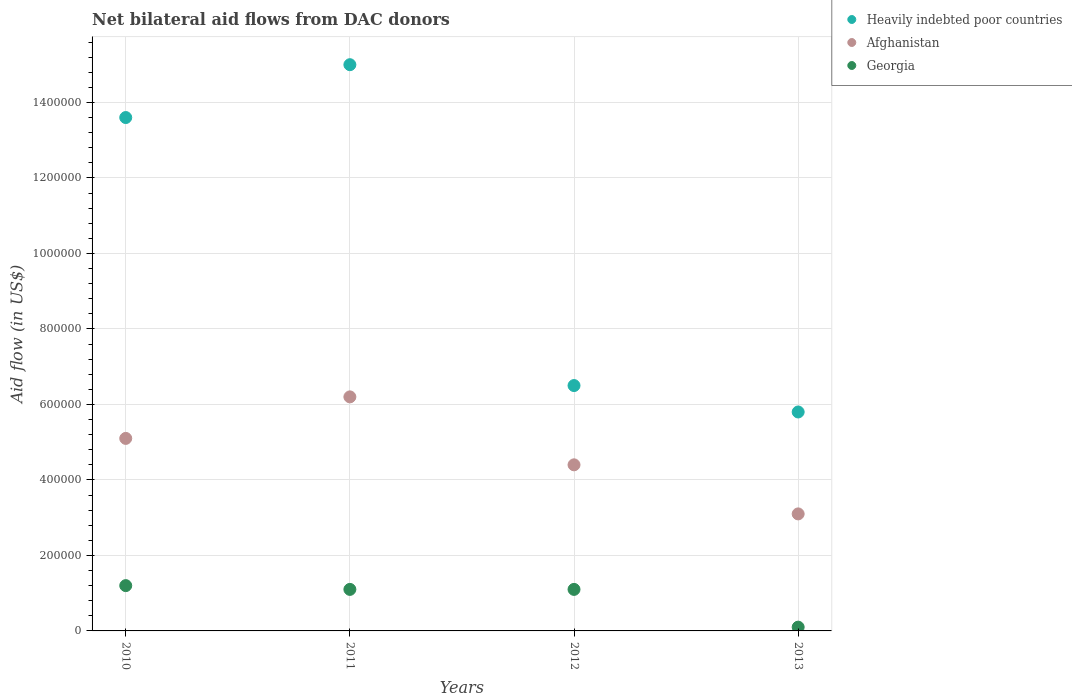What is the net bilateral aid flow in Heavily indebted poor countries in 2010?
Offer a terse response. 1.36e+06. Across all years, what is the maximum net bilateral aid flow in Afghanistan?
Keep it short and to the point. 6.20e+05. Across all years, what is the minimum net bilateral aid flow in Heavily indebted poor countries?
Offer a terse response. 5.80e+05. In which year was the net bilateral aid flow in Georgia maximum?
Provide a short and direct response. 2010. In which year was the net bilateral aid flow in Afghanistan minimum?
Your response must be concise. 2013. What is the total net bilateral aid flow in Heavily indebted poor countries in the graph?
Provide a short and direct response. 4.09e+06. What is the difference between the net bilateral aid flow in Afghanistan in 2010 and that in 2011?
Give a very brief answer. -1.10e+05. What is the difference between the net bilateral aid flow in Afghanistan in 2013 and the net bilateral aid flow in Heavily indebted poor countries in 2012?
Your answer should be compact. -3.40e+05. What is the average net bilateral aid flow in Heavily indebted poor countries per year?
Provide a short and direct response. 1.02e+06. In the year 2012, what is the difference between the net bilateral aid flow in Heavily indebted poor countries and net bilateral aid flow in Georgia?
Give a very brief answer. 5.40e+05. Is the net bilateral aid flow in Afghanistan in 2010 less than that in 2011?
Ensure brevity in your answer.  Yes. Is the difference between the net bilateral aid flow in Heavily indebted poor countries in 2011 and 2013 greater than the difference between the net bilateral aid flow in Georgia in 2011 and 2013?
Provide a succinct answer. Yes. What is the difference between the highest and the second highest net bilateral aid flow in Georgia?
Offer a terse response. 10000. What is the difference between the highest and the lowest net bilateral aid flow in Georgia?
Provide a short and direct response. 1.10e+05. Is the sum of the net bilateral aid flow in Georgia in 2011 and 2012 greater than the maximum net bilateral aid flow in Heavily indebted poor countries across all years?
Keep it short and to the point. No. Is it the case that in every year, the sum of the net bilateral aid flow in Heavily indebted poor countries and net bilateral aid flow in Afghanistan  is greater than the net bilateral aid flow in Georgia?
Offer a very short reply. Yes. Does the net bilateral aid flow in Georgia monotonically increase over the years?
Ensure brevity in your answer.  No. Is the net bilateral aid flow in Heavily indebted poor countries strictly greater than the net bilateral aid flow in Georgia over the years?
Ensure brevity in your answer.  Yes. Is the net bilateral aid flow in Georgia strictly less than the net bilateral aid flow in Afghanistan over the years?
Ensure brevity in your answer.  Yes. How many dotlines are there?
Offer a terse response. 3. What is the difference between two consecutive major ticks on the Y-axis?
Your response must be concise. 2.00e+05. Where does the legend appear in the graph?
Offer a very short reply. Top right. How many legend labels are there?
Your answer should be very brief. 3. How are the legend labels stacked?
Ensure brevity in your answer.  Vertical. What is the title of the graph?
Make the answer very short. Net bilateral aid flows from DAC donors. Does "Jamaica" appear as one of the legend labels in the graph?
Give a very brief answer. No. What is the label or title of the Y-axis?
Your answer should be compact. Aid flow (in US$). What is the Aid flow (in US$) of Heavily indebted poor countries in 2010?
Provide a succinct answer. 1.36e+06. What is the Aid flow (in US$) in Afghanistan in 2010?
Your answer should be compact. 5.10e+05. What is the Aid flow (in US$) of Heavily indebted poor countries in 2011?
Offer a very short reply. 1.50e+06. What is the Aid flow (in US$) in Afghanistan in 2011?
Ensure brevity in your answer.  6.20e+05. What is the Aid flow (in US$) of Heavily indebted poor countries in 2012?
Your answer should be compact. 6.50e+05. What is the Aid flow (in US$) of Afghanistan in 2012?
Keep it short and to the point. 4.40e+05. What is the Aid flow (in US$) of Georgia in 2012?
Provide a succinct answer. 1.10e+05. What is the Aid flow (in US$) of Heavily indebted poor countries in 2013?
Provide a short and direct response. 5.80e+05. What is the Aid flow (in US$) in Georgia in 2013?
Provide a succinct answer. 10000. Across all years, what is the maximum Aid flow (in US$) in Heavily indebted poor countries?
Keep it short and to the point. 1.50e+06. Across all years, what is the maximum Aid flow (in US$) of Afghanistan?
Your response must be concise. 6.20e+05. Across all years, what is the maximum Aid flow (in US$) in Georgia?
Ensure brevity in your answer.  1.20e+05. Across all years, what is the minimum Aid flow (in US$) of Heavily indebted poor countries?
Keep it short and to the point. 5.80e+05. Across all years, what is the minimum Aid flow (in US$) in Georgia?
Keep it short and to the point. 10000. What is the total Aid flow (in US$) in Heavily indebted poor countries in the graph?
Offer a terse response. 4.09e+06. What is the total Aid flow (in US$) of Afghanistan in the graph?
Offer a very short reply. 1.88e+06. What is the total Aid flow (in US$) in Georgia in the graph?
Give a very brief answer. 3.50e+05. What is the difference between the Aid flow (in US$) of Georgia in 2010 and that in 2011?
Offer a terse response. 10000. What is the difference between the Aid flow (in US$) of Heavily indebted poor countries in 2010 and that in 2012?
Keep it short and to the point. 7.10e+05. What is the difference between the Aid flow (in US$) in Heavily indebted poor countries in 2010 and that in 2013?
Make the answer very short. 7.80e+05. What is the difference between the Aid flow (in US$) in Afghanistan in 2010 and that in 2013?
Keep it short and to the point. 2.00e+05. What is the difference between the Aid flow (in US$) in Heavily indebted poor countries in 2011 and that in 2012?
Offer a very short reply. 8.50e+05. What is the difference between the Aid flow (in US$) in Afghanistan in 2011 and that in 2012?
Your answer should be compact. 1.80e+05. What is the difference between the Aid flow (in US$) of Heavily indebted poor countries in 2011 and that in 2013?
Your response must be concise. 9.20e+05. What is the difference between the Aid flow (in US$) of Afghanistan in 2011 and that in 2013?
Offer a terse response. 3.10e+05. What is the difference between the Aid flow (in US$) in Heavily indebted poor countries in 2012 and that in 2013?
Provide a succinct answer. 7.00e+04. What is the difference between the Aid flow (in US$) in Afghanistan in 2012 and that in 2013?
Your response must be concise. 1.30e+05. What is the difference between the Aid flow (in US$) in Georgia in 2012 and that in 2013?
Offer a very short reply. 1.00e+05. What is the difference between the Aid flow (in US$) in Heavily indebted poor countries in 2010 and the Aid flow (in US$) in Afghanistan in 2011?
Give a very brief answer. 7.40e+05. What is the difference between the Aid flow (in US$) of Heavily indebted poor countries in 2010 and the Aid flow (in US$) of Georgia in 2011?
Offer a terse response. 1.25e+06. What is the difference between the Aid flow (in US$) of Heavily indebted poor countries in 2010 and the Aid flow (in US$) of Afghanistan in 2012?
Your answer should be compact. 9.20e+05. What is the difference between the Aid flow (in US$) in Heavily indebted poor countries in 2010 and the Aid flow (in US$) in Georgia in 2012?
Your answer should be compact. 1.25e+06. What is the difference between the Aid flow (in US$) of Afghanistan in 2010 and the Aid flow (in US$) of Georgia in 2012?
Your answer should be very brief. 4.00e+05. What is the difference between the Aid flow (in US$) in Heavily indebted poor countries in 2010 and the Aid flow (in US$) in Afghanistan in 2013?
Offer a terse response. 1.05e+06. What is the difference between the Aid flow (in US$) of Heavily indebted poor countries in 2010 and the Aid flow (in US$) of Georgia in 2013?
Make the answer very short. 1.35e+06. What is the difference between the Aid flow (in US$) of Afghanistan in 2010 and the Aid flow (in US$) of Georgia in 2013?
Ensure brevity in your answer.  5.00e+05. What is the difference between the Aid flow (in US$) of Heavily indebted poor countries in 2011 and the Aid flow (in US$) of Afghanistan in 2012?
Keep it short and to the point. 1.06e+06. What is the difference between the Aid flow (in US$) in Heavily indebted poor countries in 2011 and the Aid flow (in US$) in Georgia in 2012?
Your answer should be very brief. 1.39e+06. What is the difference between the Aid flow (in US$) in Afghanistan in 2011 and the Aid flow (in US$) in Georgia in 2012?
Keep it short and to the point. 5.10e+05. What is the difference between the Aid flow (in US$) of Heavily indebted poor countries in 2011 and the Aid flow (in US$) of Afghanistan in 2013?
Provide a succinct answer. 1.19e+06. What is the difference between the Aid flow (in US$) of Heavily indebted poor countries in 2011 and the Aid flow (in US$) of Georgia in 2013?
Provide a short and direct response. 1.49e+06. What is the difference between the Aid flow (in US$) of Heavily indebted poor countries in 2012 and the Aid flow (in US$) of Afghanistan in 2013?
Offer a very short reply. 3.40e+05. What is the difference between the Aid flow (in US$) in Heavily indebted poor countries in 2012 and the Aid flow (in US$) in Georgia in 2013?
Provide a succinct answer. 6.40e+05. What is the difference between the Aid flow (in US$) in Afghanistan in 2012 and the Aid flow (in US$) in Georgia in 2013?
Offer a terse response. 4.30e+05. What is the average Aid flow (in US$) in Heavily indebted poor countries per year?
Your answer should be compact. 1.02e+06. What is the average Aid flow (in US$) of Georgia per year?
Offer a very short reply. 8.75e+04. In the year 2010, what is the difference between the Aid flow (in US$) of Heavily indebted poor countries and Aid flow (in US$) of Afghanistan?
Provide a short and direct response. 8.50e+05. In the year 2010, what is the difference between the Aid flow (in US$) of Heavily indebted poor countries and Aid flow (in US$) of Georgia?
Provide a short and direct response. 1.24e+06. In the year 2011, what is the difference between the Aid flow (in US$) in Heavily indebted poor countries and Aid flow (in US$) in Afghanistan?
Make the answer very short. 8.80e+05. In the year 2011, what is the difference between the Aid flow (in US$) of Heavily indebted poor countries and Aid flow (in US$) of Georgia?
Your answer should be compact. 1.39e+06. In the year 2011, what is the difference between the Aid flow (in US$) in Afghanistan and Aid flow (in US$) in Georgia?
Offer a terse response. 5.10e+05. In the year 2012, what is the difference between the Aid flow (in US$) of Heavily indebted poor countries and Aid flow (in US$) of Georgia?
Give a very brief answer. 5.40e+05. In the year 2013, what is the difference between the Aid flow (in US$) of Heavily indebted poor countries and Aid flow (in US$) of Georgia?
Ensure brevity in your answer.  5.70e+05. In the year 2013, what is the difference between the Aid flow (in US$) of Afghanistan and Aid flow (in US$) of Georgia?
Provide a short and direct response. 3.00e+05. What is the ratio of the Aid flow (in US$) in Heavily indebted poor countries in 2010 to that in 2011?
Your answer should be very brief. 0.91. What is the ratio of the Aid flow (in US$) of Afghanistan in 2010 to that in 2011?
Keep it short and to the point. 0.82. What is the ratio of the Aid flow (in US$) in Heavily indebted poor countries in 2010 to that in 2012?
Your answer should be compact. 2.09. What is the ratio of the Aid flow (in US$) of Afghanistan in 2010 to that in 2012?
Make the answer very short. 1.16. What is the ratio of the Aid flow (in US$) of Heavily indebted poor countries in 2010 to that in 2013?
Offer a terse response. 2.34. What is the ratio of the Aid flow (in US$) in Afghanistan in 2010 to that in 2013?
Make the answer very short. 1.65. What is the ratio of the Aid flow (in US$) of Georgia in 2010 to that in 2013?
Give a very brief answer. 12. What is the ratio of the Aid flow (in US$) in Heavily indebted poor countries in 2011 to that in 2012?
Your response must be concise. 2.31. What is the ratio of the Aid flow (in US$) of Afghanistan in 2011 to that in 2012?
Provide a short and direct response. 1.41. What is the ratio of the Aid flow (in US$) of Heavily indebted poor countries in 2011 to that in 2013?
Ensure brevity in your answer.  2.59. What is the ratio of the Aid flow (in US$) of Afghanistan in 2011 to that in 2013?
Keep it short and to the point. 2. What is the ratio of the Aid flow (in US$) of Georgia in 2011 to that in 2013?
Provide a succinct answer. 11. What is the ratio of the Aid flow (in US$) in Heavily indebted poor countries in 2012 to that in 2013?
Provide a short and direct response. 1.12. What is the ratio of the Aid flow (in US$) in Afghanistan in 2012 to that in 2013?
Offer a very short reply. 1.42. What is the ratio of the Aid flow (in US$) in Georgia in 2012 to that in 2013?
Provide a short and direct response. 11. What is the difference between the highest and the lowest Aid flow (in US$) in Heavily indebted poor countries?
Provide a succinct answer. 9.20e+05. 